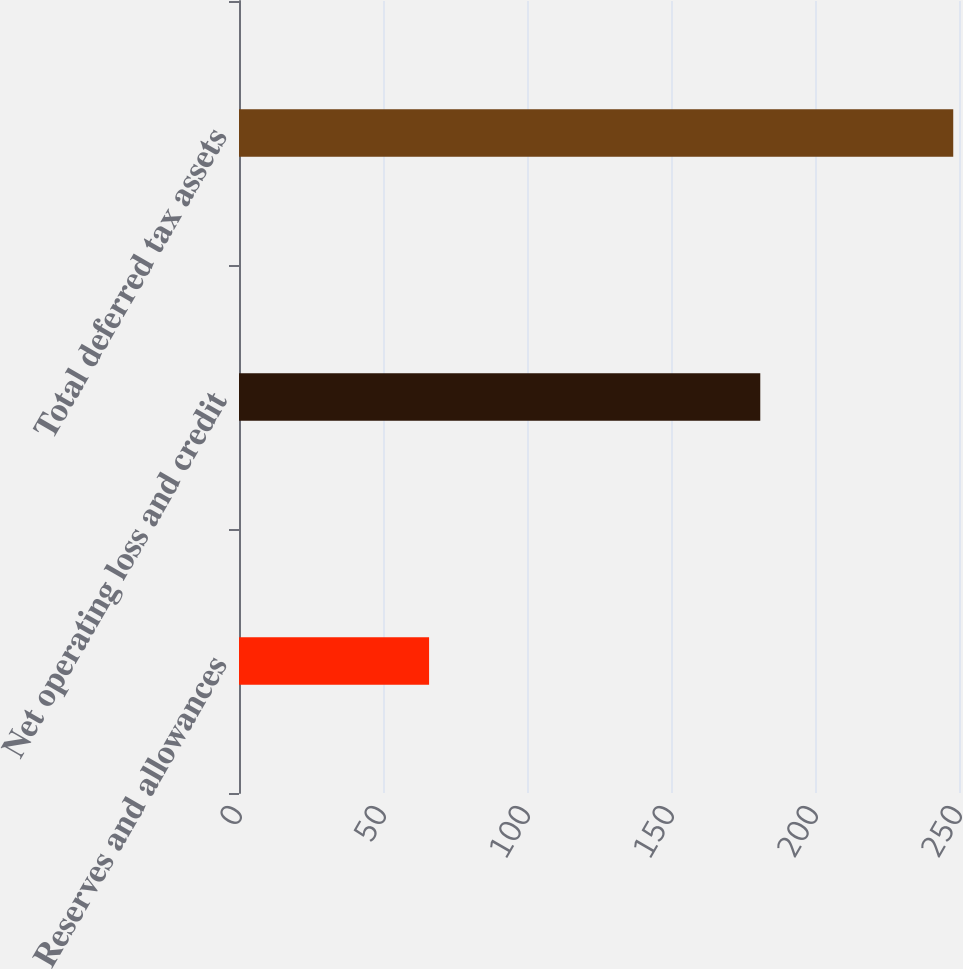Convert chart to OTSL. <chart><loc_0><loc_0><loc_500><loc_500><bar_chart><fcel>Reserves and allowances<fcel>Net operating loss and credit<fcel>Total deferred tax assets<nl><fcel>66<fcel>181<fcel>248<nl></chart> 